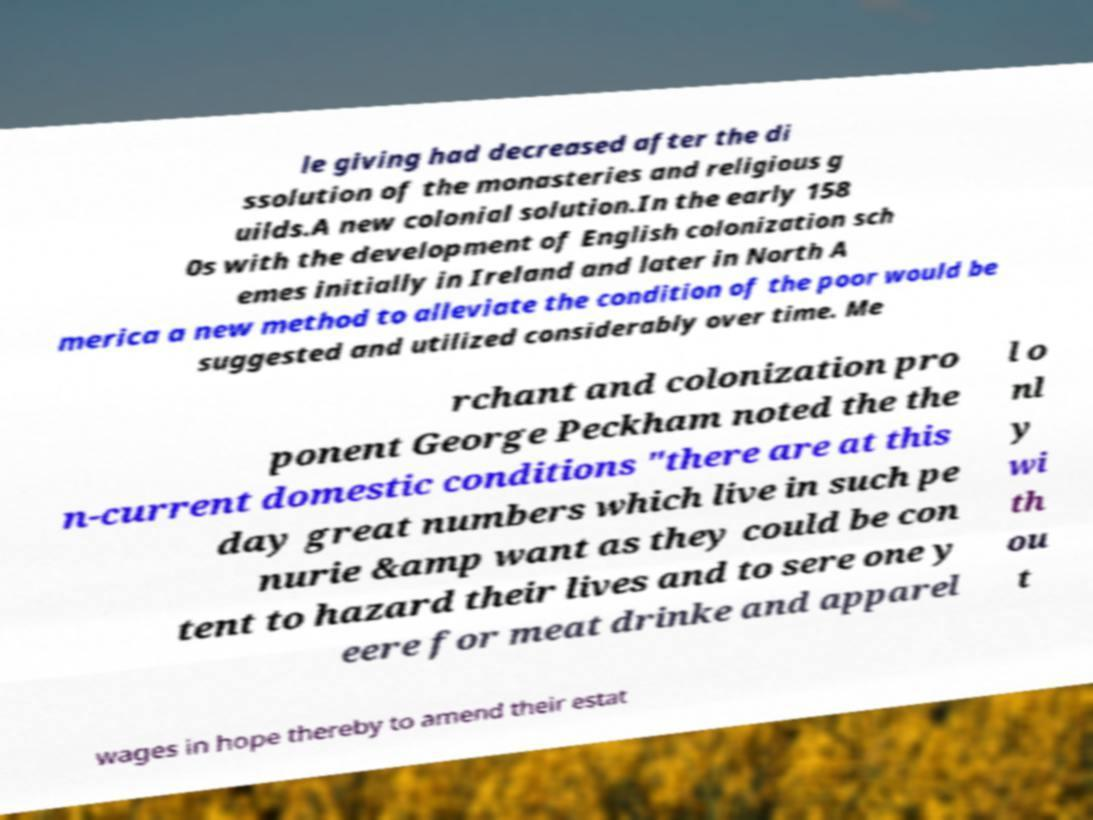There's text embedded in this image that I need extracted. Can you transcribe it verbatim? le giving had decreased after the di ssolution of the monasteries and religious g uilds.A new colonial solution.In the early 158 0s with the development of English colonization sch emes initially in Ireland and later in North A merica a new method to alleviate the condition of the poor would be suggested and utilized considerably over time. Me rchant and colonization pro ponent George Peckham noted the the n-current domestic conditions "there are at this day great numbers which live in such pe nurie &amp want as they could be con tent to hazard their lives and to sere one y eere for meat drinke and apparel l o nl y wi th ou t wages in hope thereby to amend their estat 